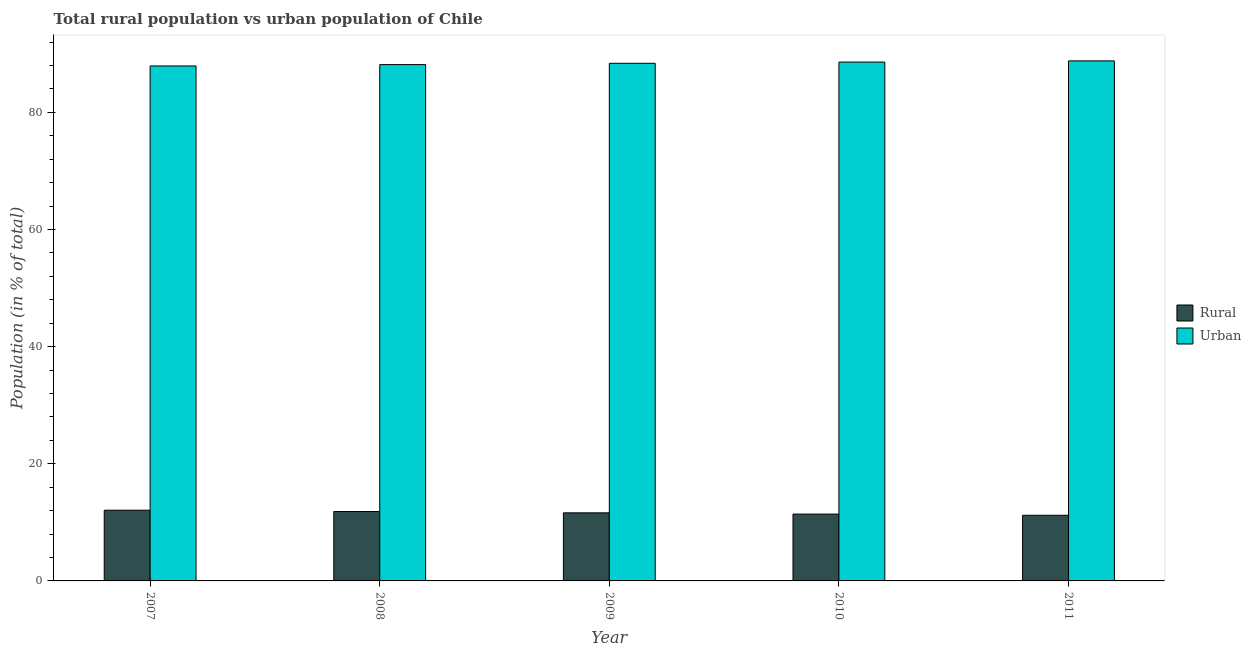What is the label of the 3rd group of bars from the left?
Keep it short and to the point. 2009. In how many cases, is the number of bars for a given year not equal to the number of legend labels?
Keep it short and to the point. 0. What is the urban population in 2011?
Your answer should be very brief. 88.79. Across all years, what is the maximum rural population?
Your answer should be very brief. 12.07. Across all years, what is the minimum urban population?
Provide a succinct answer. 87.93. In which year was the rural population minimum?
Give a very brief answer. 2011. What is the total rural population in the graph?
Provide a succinct answer. 58.17. What is the difference between the rural population in 2008 and that in 2009?
Keep it short and to the point. 0.22. What is the difference between the rural population in 2011 and the urban population in 2007?
Offer a terse response. -0.86. What is the average rural population per year?
Your response must be concise. 11.63. In the year 2011, what is the difference between the rural population and urban population?
Keep it short and to the point. 0. In how many years, is the rural population greater than 4 %?
Offer a very short reply. 5. What is the ratio of the rural population in 2007 to that in 2008?
Give a very brief answer. 1.02. Is the urban population in 2007 less than that in 2009?
Make the answer very short. Yes. What is the difference between the highest and the second highest rural population?
Ensure brevity in your answer.  0.23. What is the difference between the highest and the lowest rural population?
Your answer should be very brief. 0.86. Is the sum of the rural population in 2009 and 2010 greater than the maximum urban population across all years?
Provide a short and direct response. Yes. What does the 2nd bar from the left in 2008 represents?
Make the answer very short. Urban. What does the 2nd bar from the right in 2008 represents?
Provide a succinct answer. Rural. How many bars are there?
Ensure brevity in your answer.  10. How many years are there in the graph?
Your answer should be very brief. 5. What is the difference between two consecutive major ticks on the Y-axis?
Keep it short and to the point. 20. Are the values on the major ticks of Y-axis written in scientific E-notation?
Your answer should be compact. No. Where does the legend appear in the graph?
Offer a very short reply. Center right. How are the legend labels stacked?
Make the answer very short. Vertical. What is the title of the graph?
Offer a terse response. Total rural population vs urban population of Chile. What is the label or title of the Y-axis?
Keep it short and to the point. Population (in % of total). What is the Population (in % of total) in Rural in 2007?
Your answer should be very brief. 12.07. What is the Population (in % of total) of Urban in 2007?
Your answer should be compact. 87.93. What is the Population (in % of total) of Rural in 2008?
Give a very brief answer. 11.85. What is the Population (in % of total) of Urban in 2008?
Provide a succinct answer. 88.16. What is the Population (in % of total) in Rural in 2009?
Keep it short and to the point. 11.62. What is the Population (in % of total) of Urban in 2009?
Your answer should be very brief. 88.38. What is the Population (in % of total) of Rural in 2010?
Your response must be concise. 11.41. What is the Population (in % of total) in Urban in 2010?
Your answer should be compact. 88.59. What is the Population (in % of total) in Rural in 2011?
Keep it short and to the point. 11.21. What is the Population (in % of total) in Urban in 2011?
Give a very brief answer. 88.79. Across all years, what is the maximum Population (in % of total) in Rural?
Provide a short and direct response. 12.07. Across all years, what is the maximum Population (in % of total) of Urban?
Keep it short and to the point. 88.79. Across all years, what is the minimum Population (in % of total) of Rural?
Offer a terse response. 11.21. Across all years, what is the minimum Population (in % of total) in Urban?
Provide a short and direct response. 87.93. What is the total Population (in % of total) of Rural in the graph?
Give a very brief answer. 58.17. What is the total Population (in % of total) of Urban in the graph?
Provide a succinct answer. 441.83. What is the difference between the Population (in % of total) of Rural in 2007 and that in 2008?
Your answer should be very brief. 0.23. What is the difference between the Population (in % of total) in Urban in 2007 and that in 2008?
Provide a succinct answer. -0.23. What is the difference between the Population (in % of total) of Rural in 2007 and that in 2009?
Your answer should be very brief. 0.45. What is the difference between the Population (in % of total) of Urban in 2007 and that in 2009?
Keep it short and to the point. -0.45. What is the difference between the Population (in % of total) in Rural in 2007 and that in 2010?
Make the answer very short. 0.66. What is the difference between the Population (in % of total) of Urban in 2007 and that in 2010?
Your response must be concise. -0.66. What is the difference between the Population (in % of total) in Rural in 2007 and that in 2011?
Keep it short and to the point. 0.86. What is the difference between the Population (in % of total) of Urban in 2007 and that in 2011?
Provide a succinct answer. -0.86. What is the difference between the Population (in % of total) in Rural in 2008 and that in 2009?
Give a very brief answer. 0.22. What is the difference between the Population (in % of total) of Urban in 2008 and that in 2009?
Offer a very short reply. -0.22. What is the difference between the Population (in % of total) in Rural in 2008 and that in 2010?
Give a very brief answer. 0.43. What is the difference between the Population (in % of total) of Urban in 2008 and that in 2010?
Offer a very short reply. -0.43. What is the difference between the Population (in % of total) in Rural in 2008 and that in 2011?
Make the answer very short. 0.64. What is the difference between the Population (in % of total) in Urban in 2008 and that in 2011?
Provide a short and direct response. -0.64. What is the difference between the Population (in % of total) of Rural in 2009 and that in 2010?
Provide a short and direct response. 0.21. What is the difference between the Population (in % of total) of Urban in 2009 and that in 2010?
Provide a short and direct response. -0.21. What is the difference between the Population (in % of total) in Rural in 2009 and that in 2011?
Offer a terse response. 0.41. What is the difference between the Population (in % of total) in Urban in 2009 and that in 2011?
Make the answer very short. -0.41. What is the difference between the Population (in % of total) in Rural in 2010 and that in 2011?
Your response must be concise. 0.2. What is the difference between the Population (in % of total) of Urban in 2010 and that in 2011?
Provide a succinct answer. -0.2. What is the difference between the Population (in % of total) of Rural in 2007 and the Population (in % of total) of Urban in 2008?
Your answer should be very brief. -76.08. What is the difference between the Population (in % of total) in Rural in 2007 and the Population (in % of total) in Urban in 2009?
Your answer should be very brief. -76.3. What is the difference between the Population (in % of total) in Rural in 2007 and the Population (in % of total) in Urban in 2010?
Keep it short and to the point. -76.51. What is the difference between the Population (in % of total) of Rural in 2007 and the Population (in % of total) of Urban in 2011?
Your answer should be very brief. -76.72. What is the difference between the Population (in % of total) of Rural in 2008 and the Population (in % of total) of Urban in 2009?
Provide a succinct answer. -76.53. What is the difference between the Population (in % of total) of Rural in 2008 and the Population (in % of total) of Urban in 2010?
Make the answer very short. -76.74. What is the difference between the Population (in % of total) in Rural in 2008 and the Population (in % of total) in Urban in 2011?
Provide a succinct answer. -76.94. What is the difference between the Population (in % of total) of Rural in 2009 and the Population (in % of total) of Urban in 2010?
Provide a succinct answer. -76.96. What is the difference between the Population (in % of total) of Rural in 2009 and the Population (in % of total) of Urban in 2011?
Provide a short and direct response. -77.17. What is the difference between the Population (in % of total) of Rural in 2010 and the Population (in % of total) of Urban in 2011?
Your response must be concise. -77.38. What is the average Population (in % of total) in Rural per year?
Give a very brief answer. 11.63. What is the average Population (in % of total) in Urban per year?
Offer a very short reply. 88.37. In the year 2007, what is the difference between the Population (in % of total) in Rural and Population (in % of total) in Urban?
Make the answer very short. -75.85. In the year 2008, what is the difference between the Population (in % of total) in Rural and Population (in % of total) in Urban?
Give a very brief answer. -76.31. In the year 2009, what is the difference between the Population (in % of total) in Rural and Population (in % of total) in Urban?
Your answer should be very brief. -76.75. In the year 2010, what is the difference between the Population (in % of total) of Rural and Population (in % of total) of Urban?
Make the answer very short. -77.17. In the year 2011, what is the difference between the Population (in % of total) in Rural and Population (in % of total) in Urban?
Provide a succinct answer. -77.58. What is the ratio of the Population (in % of total) in Rural in 2007 to that in 2008?
Give a very brief answer. 1.02. What is the ratio of the Population (in % of total) of Urban in 2007 to that in 2008?
Your answer should be compact. 1. What is the ratio of the Population (in % of total) in Rural in 2007 to that in 2009?
Your answer should be compact. 1.04. What is the ratio of the Population (in % of total) in Urban in 2007 to that in 2009?
Ensure brevity in your answer.  0.99. What is the ratio of the Population (in % of total) of Rural in 2007 to that in 2010?
Provide a short and direct response. 1.06. What is the ratio of the Population (in % of total) in Urban in 2007 to that in 2010?
Your answer should be very brief. 0.99. What is the ratio of the Population (in % of total) of Rural in 2007 to that in 2011?
Your answer should be compact. 1.08. What is the ratio of the Population (in % of total) of Urban in 2007 to that in 2011?
Provide a succinct answer. 0.99. What is the ratio of the Population (in % of total) of Rural in 2008 to that in 2009?
Your answer should be very brief. 1.02. What is the ratio of the Population (in % of total) of Rural in 2008 to that in 2010?
Give a very brief answer. 1.04. What is the ratio of the Population (in % of total) in Rural in 2008 to that in 2011?
Offer a very short reply. 1.06. What is the ratio of the Population (in % of total) of Urban in 2008 to that in 2011?
Provide a short and direct response. 0.99. What is the ratio of the Population (in % of total) in Rural in 2009 to that in 2010?
Give a very brief answer. 1.02. What is the ratio of the Population (in % of total) in Urban in 2009 to that in 2011?
Provide a succinct answer. 1. What is the ratio of the Population (in % of total) in Rural in 2010 to that in 2011?
Make the answer very short. 1.02. What is the ratio of the Population (in % of total) in Urban in 2010 to that in 2011?
Make the answer very short. 1. What is the difference between the highest and the second highest Population (in % of total) in Rural?
Ensure brevity in your answer.  0.23. What is the difference between the highest and the second highest Population (in % of total) of Urban?
Give a very brief answer. 0.2. What is the difference between the highest and the lowest Population (in % of total) in Rural?
Give a very brief answer. 0.86. What is the difference between the highest and the lowest Population (in % of total) in Urban?
Offer a very short reply. 0.86. 